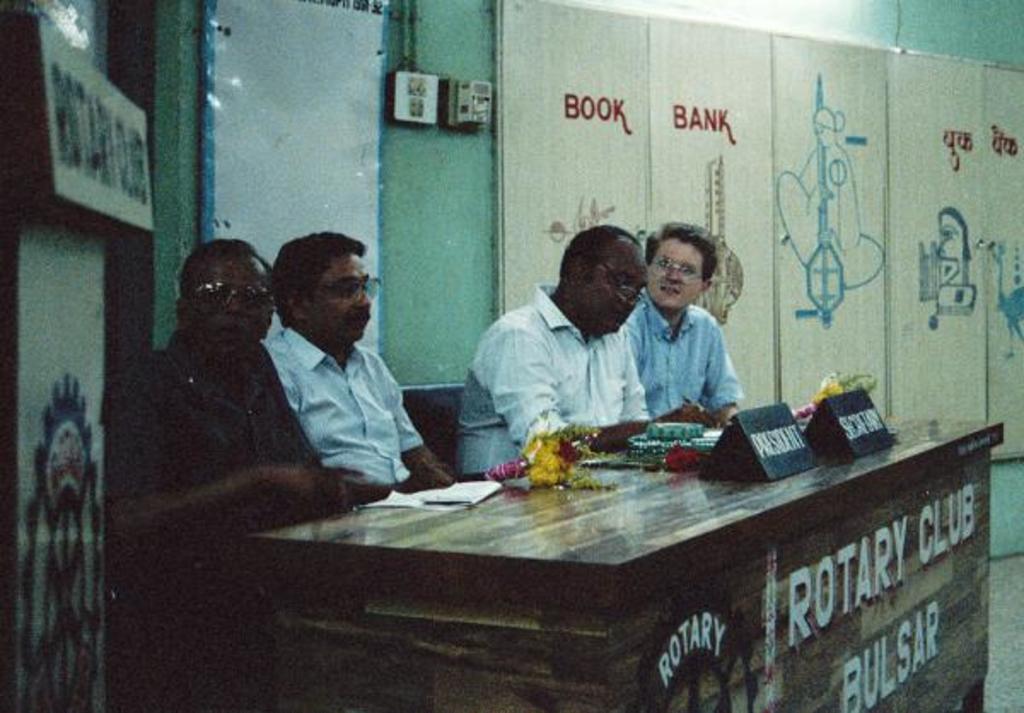How would you summarize this image in a sentence or two? In this picture, we see four men sitting on the chairs in front of the table on which paper, flower bouquet and name boards are placed. Behind them, we see a green wall and white board. On the right corner of the picture, we see a board with some text written on it. 